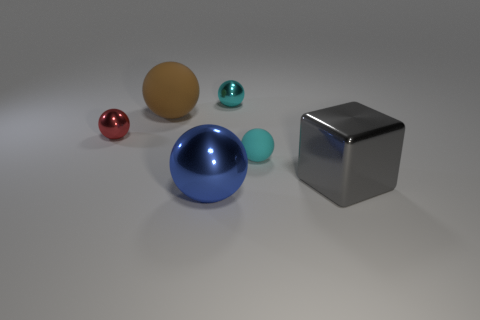Subtract all blue metallic spheres. How many spheres are left? 4 Add 3 gray shiny cylinders. How many objects exist? 9 Subtract all blue balls. How many balls are left? 4 Subtract 4 spheres. How many spheres are left? 1 Subtract 0 purple cubes. How many objects are left? 6 Subtract all spheres. How many objects are left? 1 Subtract all purple blocks. Subtract all red cylinders. How many blocks are left? 1 Subtract all purple blocks. How many gray spheres are left? 0 Subtract all cyan rubber cylinders. Subtract all matte balls. How many objects are left? 4 Add 5 small cyan metallic things. How many small cyan metallic things are left? 6 